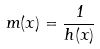<formula> <loc_0><loc_0><loc_500><loc_500>m ( x ) = \frac { 1 } { h ( x ) }</formula> 